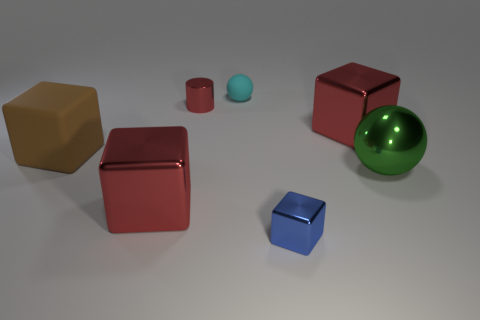How big is the object that is in front of the brown matte block and left of the red cylinder?
Keep it short and to the point. Large. Are there fewer red shiny cylinders behind the tiny cyan rubber sphere than tiny blue objects that are behind the big brown rubber object?
Provide a short and direct response. No. Do the red block on the right side of the red cylinder and the tiny cyan thing that is left of the metallic sphere have the same material?
Keep it short and to the point. No. There is a object that is in front of the large ball and right of the tiny red thing; what shape is it?
Provide a succinct answer. Cube. What material is the sphere behind the small shiny thing behind the blue object?
Your answer should be very brief. Rubber. Is the number of big green shiny balls greater than the number of red objects?
Give a very brief answer. No. Is the color of the tiny rubber ball the same as the cylinder?
Offer a very short reply. No. There is a brown cube that is the same size as the metal ball; what is it made of?
Your response must be concise. Rubber. Does the large brown block have the same material as the blue block?
Ensure brevity in your answer.  No. What number of blocks have the same material as the green ball?
Your response must be concise. 3. 